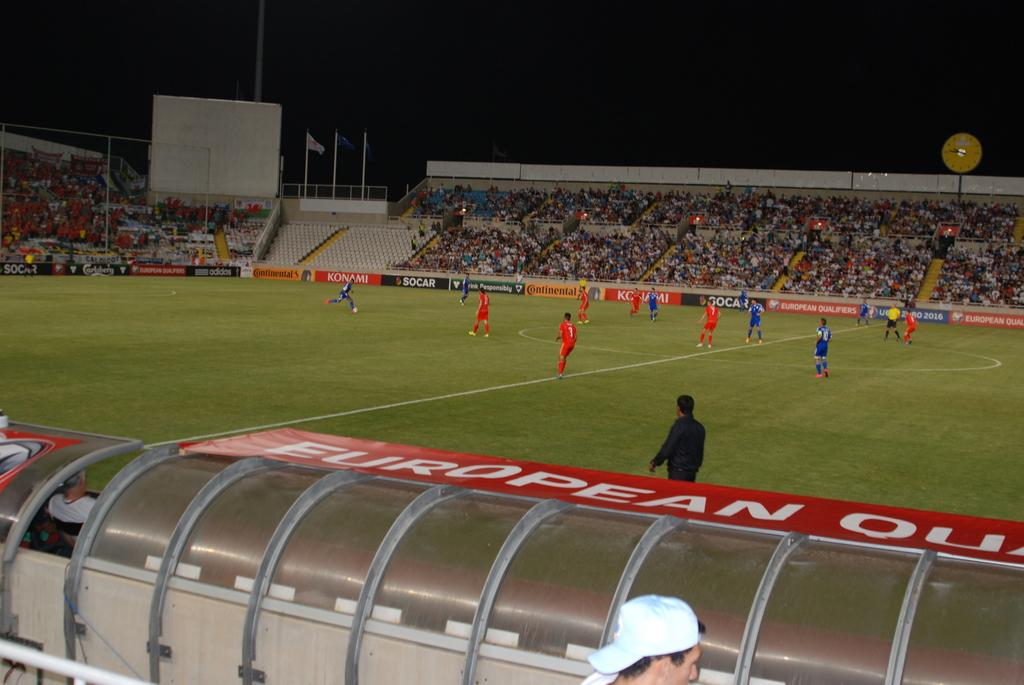<image>
Provide a brief description of the given image. A soccer game is being played on a field that has sponsors from Konami, adidas, and Continental. 